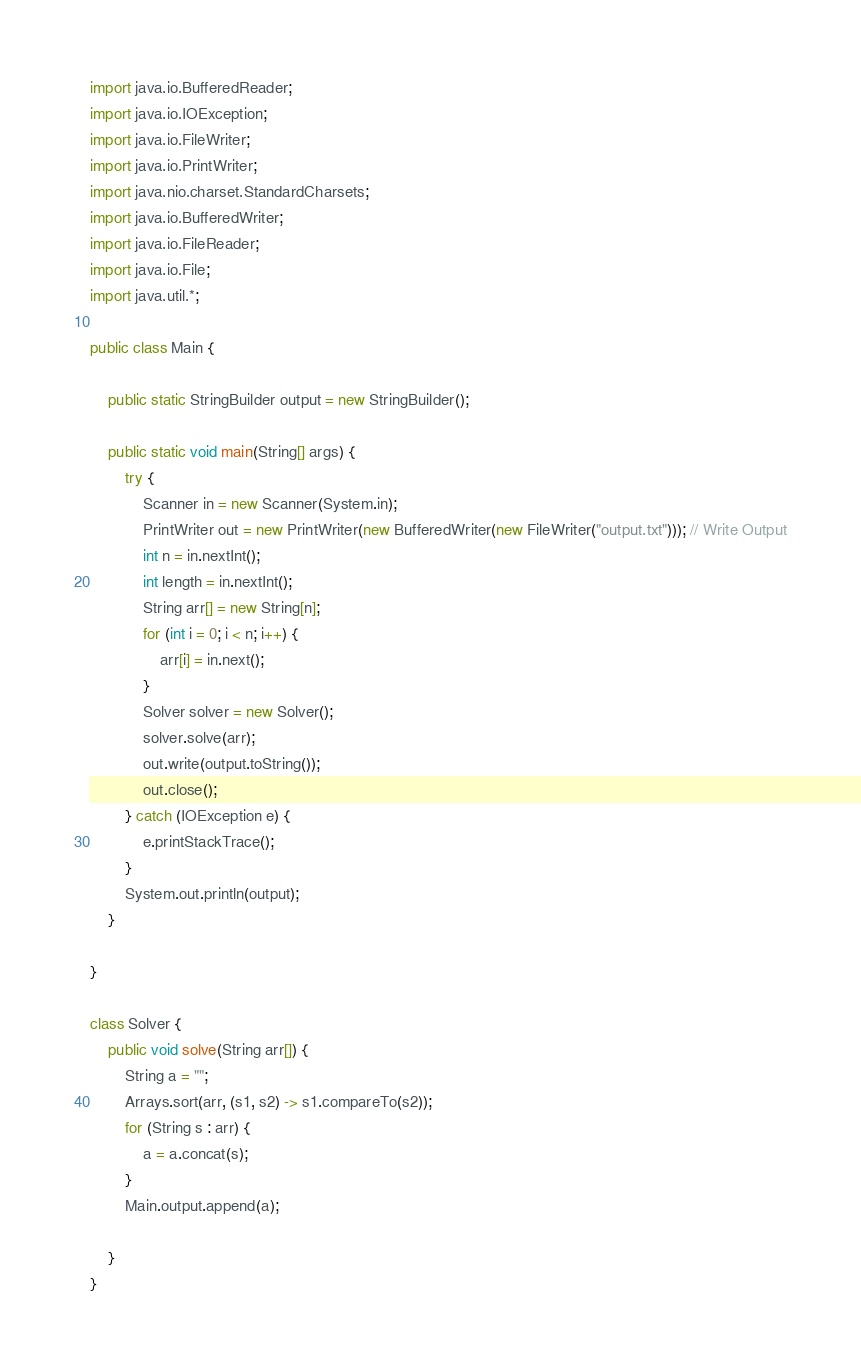<code> <loc_0><loc_0><loc_500><loc_500><_Java_>import java.io.BufferedReader;
import java.io.IOException;
import java.io.FileWriter;
import java.io.PrintWriter;
import java.nio.charset.StandardCharsets;
import java.io.BufferedWriter;
import java.io.FileReader;
import java.io.File;
import java.util.*;

public class Main {

    public static StringBuilder output = new StringBuilder();

    public static void main(String[] args) {
        try {
            Scanner in = new Scanner(System.in);
            PrintWriter out = new PrintWriter(new BufferedWriter(new FileWriter("output.txt"))); // Write Output
            int n = in.nextInt();
            int length = in.nextInt();
            String arr[] = new String[n];
            for (int i = 0; i < n; i++) {
                arr[i] = in.next();
            }
            Solver solver = new Solver();
            solver.solve(arr);
            out.write(output.toString());
            out.close();
        } catch (IOException e) {
            e.printStackTrace();
        }
        System.out.println(output);
    }

}

class Solver {
    public void solve(String arr[]) {
        String a = "";
        Arrays.sort(arr, (s1, s2) -> s1.compareTo(s2));
        for (String s : arr) {
            a = a.concat(s);
        }
        Main.output.append(a);

    }
}</code> 